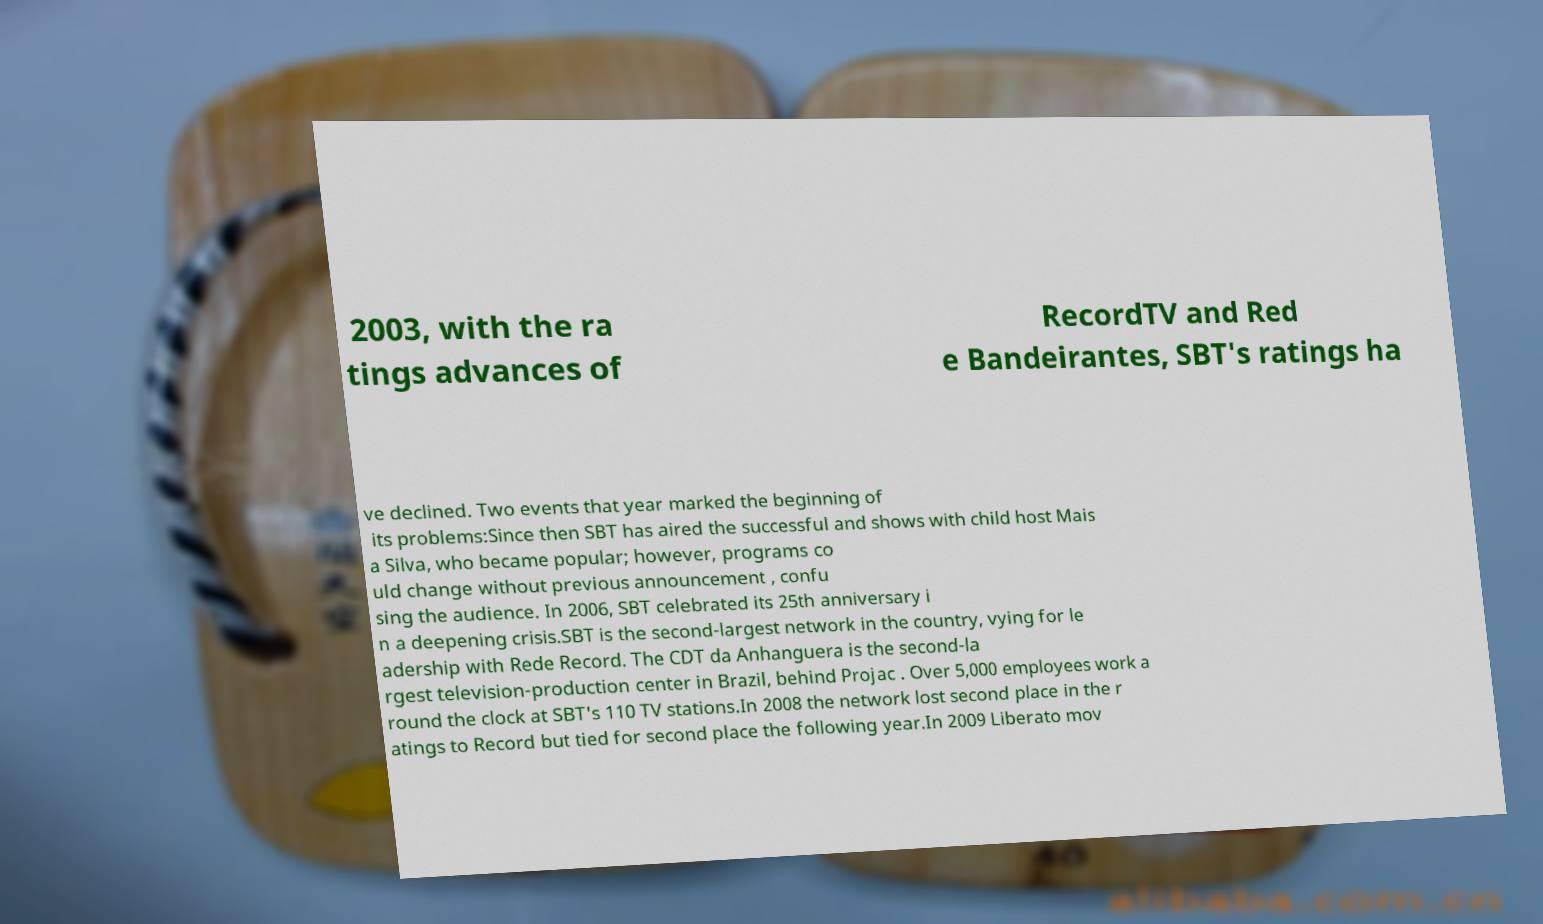What messages or text are displayed in this image? I need them in a readable, typed format. 2003, with the ra tings advances of RecordTV and Red e Bandeirantes, SBT's ratings ha ve declined. Two events that year marked the beginning of its problems:Since then SBT has aired the successful and shows with child host Mais a Silva, who became popular; however, programs co uld change without previous announcement , confu sing the audience. In 2006, SBT celebrated its 25th anniversary i n a deepening crisis.SBT is the second-largest network in the country, vying for le adership with Rede Record. The CDT da Anhanguera is the second-la rgest television-production center in Brazil, behind Projac . Over 5,000 employees work a round the clock at SBT's 110 TV stations.In 2008 the network lost second place in the r atings to Record but tied for second place the following year.In 2009 Liberato mov 